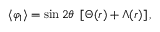Convert formula to latex. <formula><loc_0><loc_0><loc_500><loc_500>\langle \varphi _ { 1 } \rangle = \sin 2 \theta \left [ \Theta ( r ) + \Lambda ( r ) \right ] ,</formula> 